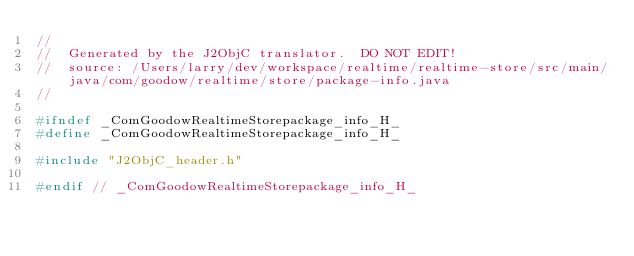<code> <loc_0><loc_0><loc_500><loc_500><_C_>//
//  Generated by the J2ObjC translator.  DO NOT EDIT!
//  source: /Users/larry/dev/workspace/realtime/realtime-store/src/main/java/com/goodow/realtime/store/package-info.java
//

#ifndef _ComGoodowRealtimeStorepackage_info_H_
#define _ComGoodowRealtimeStorepackage_info_H_

#include "J2ObjC_header.h"

#endif // _ComGoodowRealtimeStorepackage_info_H_
</code> 